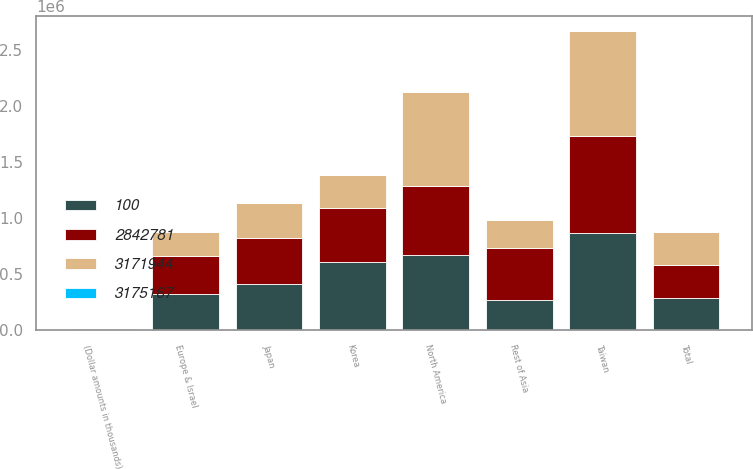<chart> <loc_0><loc_0><loc_500><loc_500><stacked_bar_chart><ecel><fcel>(Dollar amounts in thousands)<fcel>North America<fcel>Taiwan<fcel>Japan<fcel>Europe & Israel<fcel>Korea<fcel>Rest of Asia<fcel>Total<nl><fcel>3.17194e+06<fcel>2013<fcel>846125<fcel>936445<fcel>310204<fcel>211121<fcel>292724<fcel>246162<fcel>292724<nl><fcel>3.17517e+06<fcel>2013<fcel>30<fcel>33<fcel>11<fcel>7<fcel>10<fcel>9<fcel>100<nl><fcel>100<fcel>2012<fcel>675034<fcel>872583<fcel>415475<fcel>323902<fcel>611462<fcel>273488<fcel>292724<nl><fcel>2.84278e+06<fcel>2011<fcel>610955<fcel>864378<fcel>413208<fcel>340249<fcel>480488<fcel>465889<fcel>292724<nl></chart> 